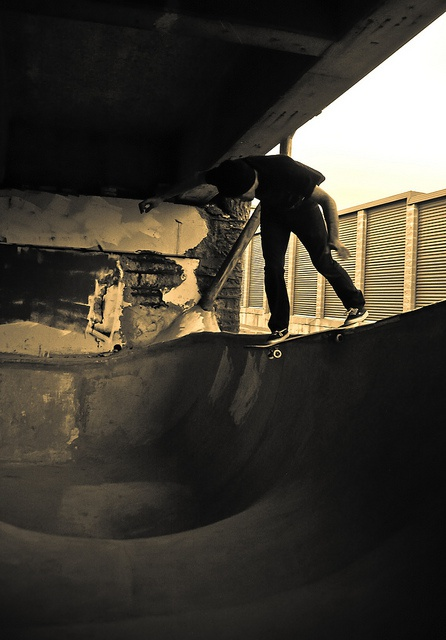Describe the objects in this image and their specific colors. I can see people in black, gray, and tan tones and skateboard in black, tan, khaki, and gray tones in this image. 